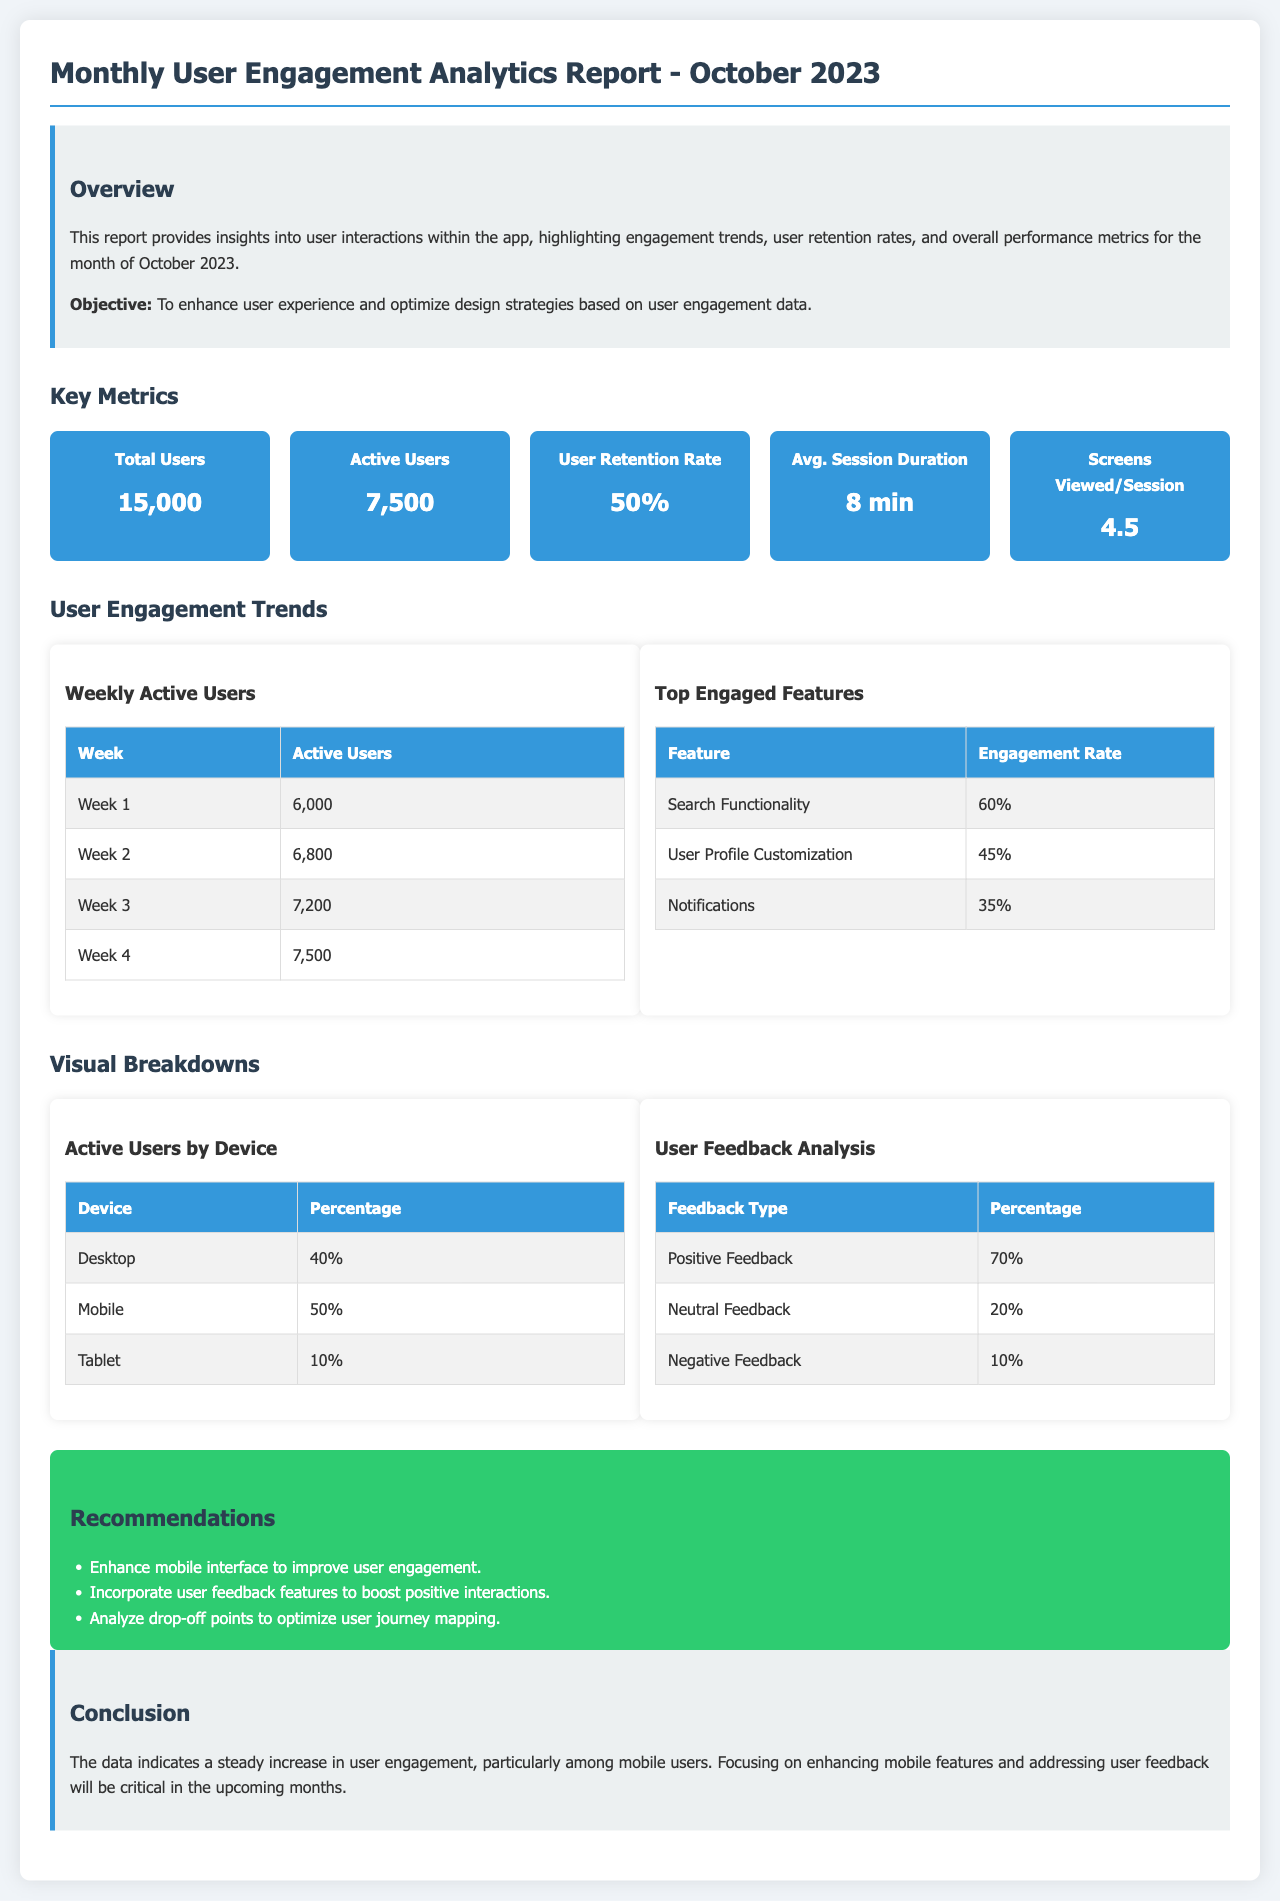What is the total number of users? The total number of users is explicitly mentioned in the metrics section of the report.
Answer: 15,000 What is the active user count? The active user count is provided in the key metrics area of the document.
Answer: 7,500 What is the user retention rate? The user retention rate is one of the key metrics listed in the report.
Answer: 50% What was the average session duration? The average session duration is provided as part of user engagement metrics.
Answer: 8 min What feature has the highest engagement rate? The highest engagement rate of features is listed in the top engaged features table.
Answer: Search Functionality Which device has the lowest percentage of active users? The active users by device statistics indicate the distribution across devices.
Answer: Tablet What is the percentage of positive feedback from users? The user feedback analysis section contains specific feedback percentages.
Answer: 70% What recommendation focuses on mobile users? The recommendations section discusses strategies related to user engagement improvement.
Answer: Enhance mobile interface What was the trend of active users over the month? The trend of active users can be inferred from the weekly active users table.
Answer: Steady increase 